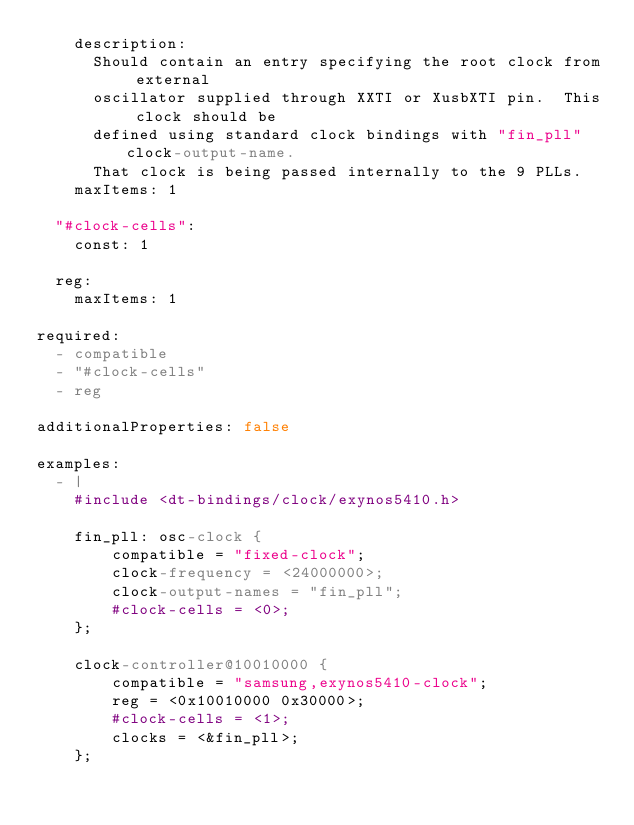<code> <loc_0><loc_0><loc_500><loc_500><_YAML_>    description:
      Should contain an entry specifying the root clock from external
      oscillator supplied through XXTI or XusbXTI pin.  This clock should be
      defined using standard clock bindings with "fin_pll" clock-output-name.
      That clock is being passed internally to the 9 PLLs.
    maxItems: 1

  "#clock-cells":
    const: 1

  reg:
    maxItems: 1

required:
  - compatible
  - "#clock-cells"
  - reg

additionalProperties: false

examples:
  - |
    #include <dt-bindings/clock/exynos5410.h>

    fin_pll: osc-clock {
        compatible = "fixed-clock";
        clock-frequency = <24000000>;
        clock-output-names = "fin_pll";
        #clock-cells = <0>;
    };

    clock-controller@10010000 {
        compatible = "samsung,exynos5410-clock";
        reg = <0x10010000 0x30000>;
        #clock-cells = <1>;
        clocks = <&fin_pll>;
    };
</code> 